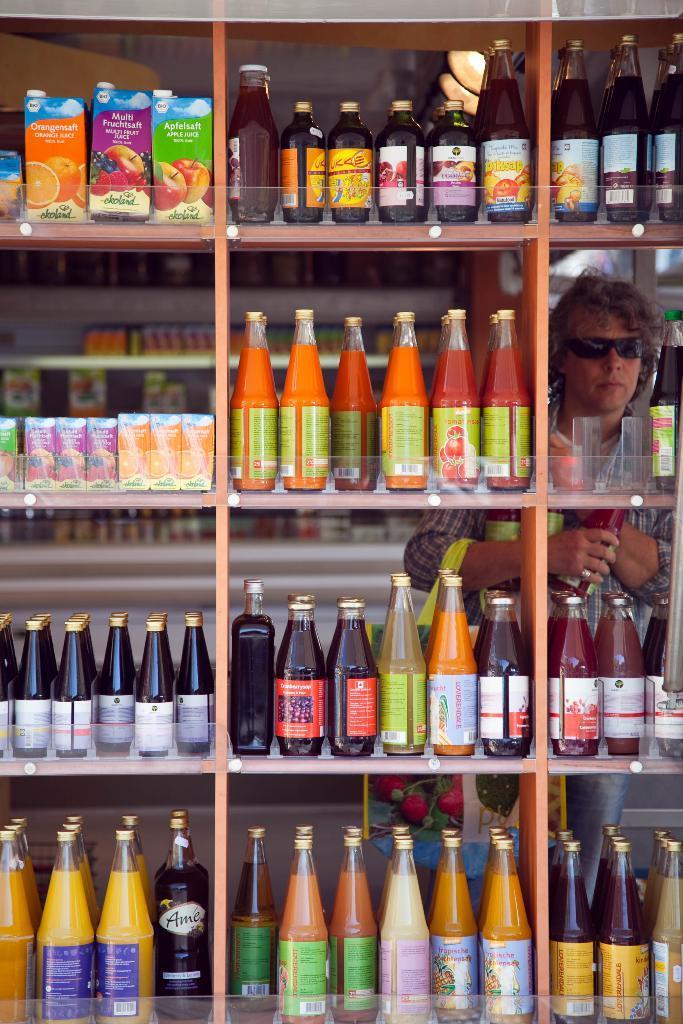How would you summarize this image in a sentence or two? The image is clicked in a store. In this image there is a man standing behind the rack. In that rock, there are many bottles kept. Those bottles looks like fruit juices and sauce. 